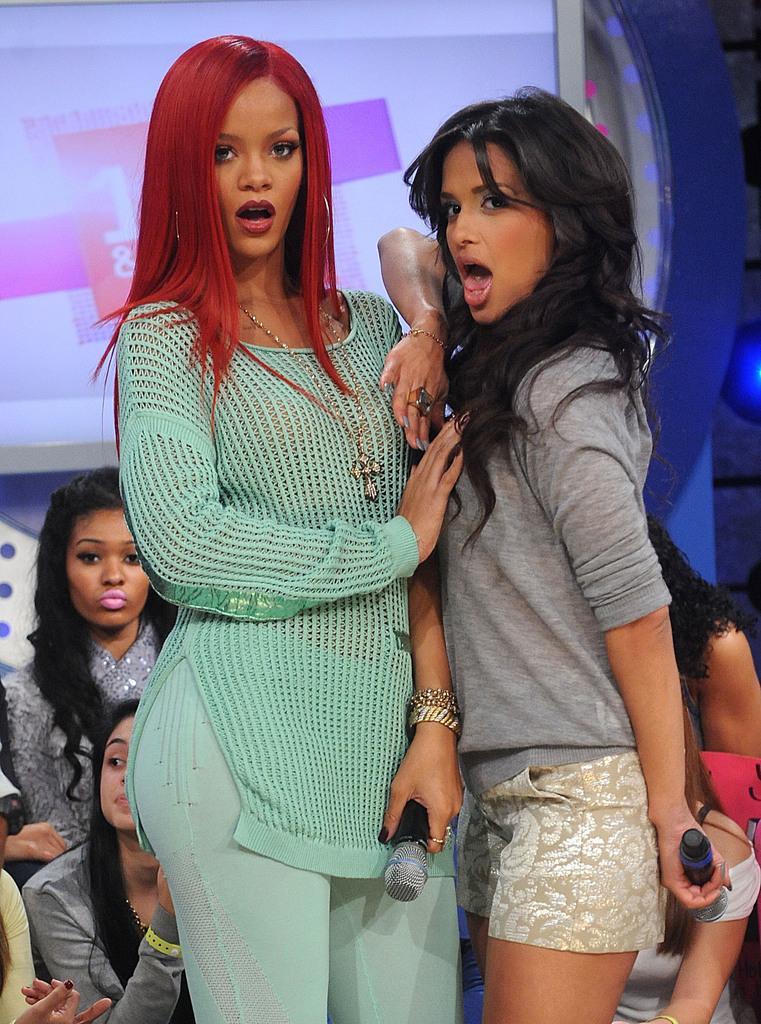In one or two sentences, can you explain what this image depicts? In this image in the front there are women standing and having expression on their faces, holding mics in their hands. In the background there are persons and there is a board with some text written on it. 